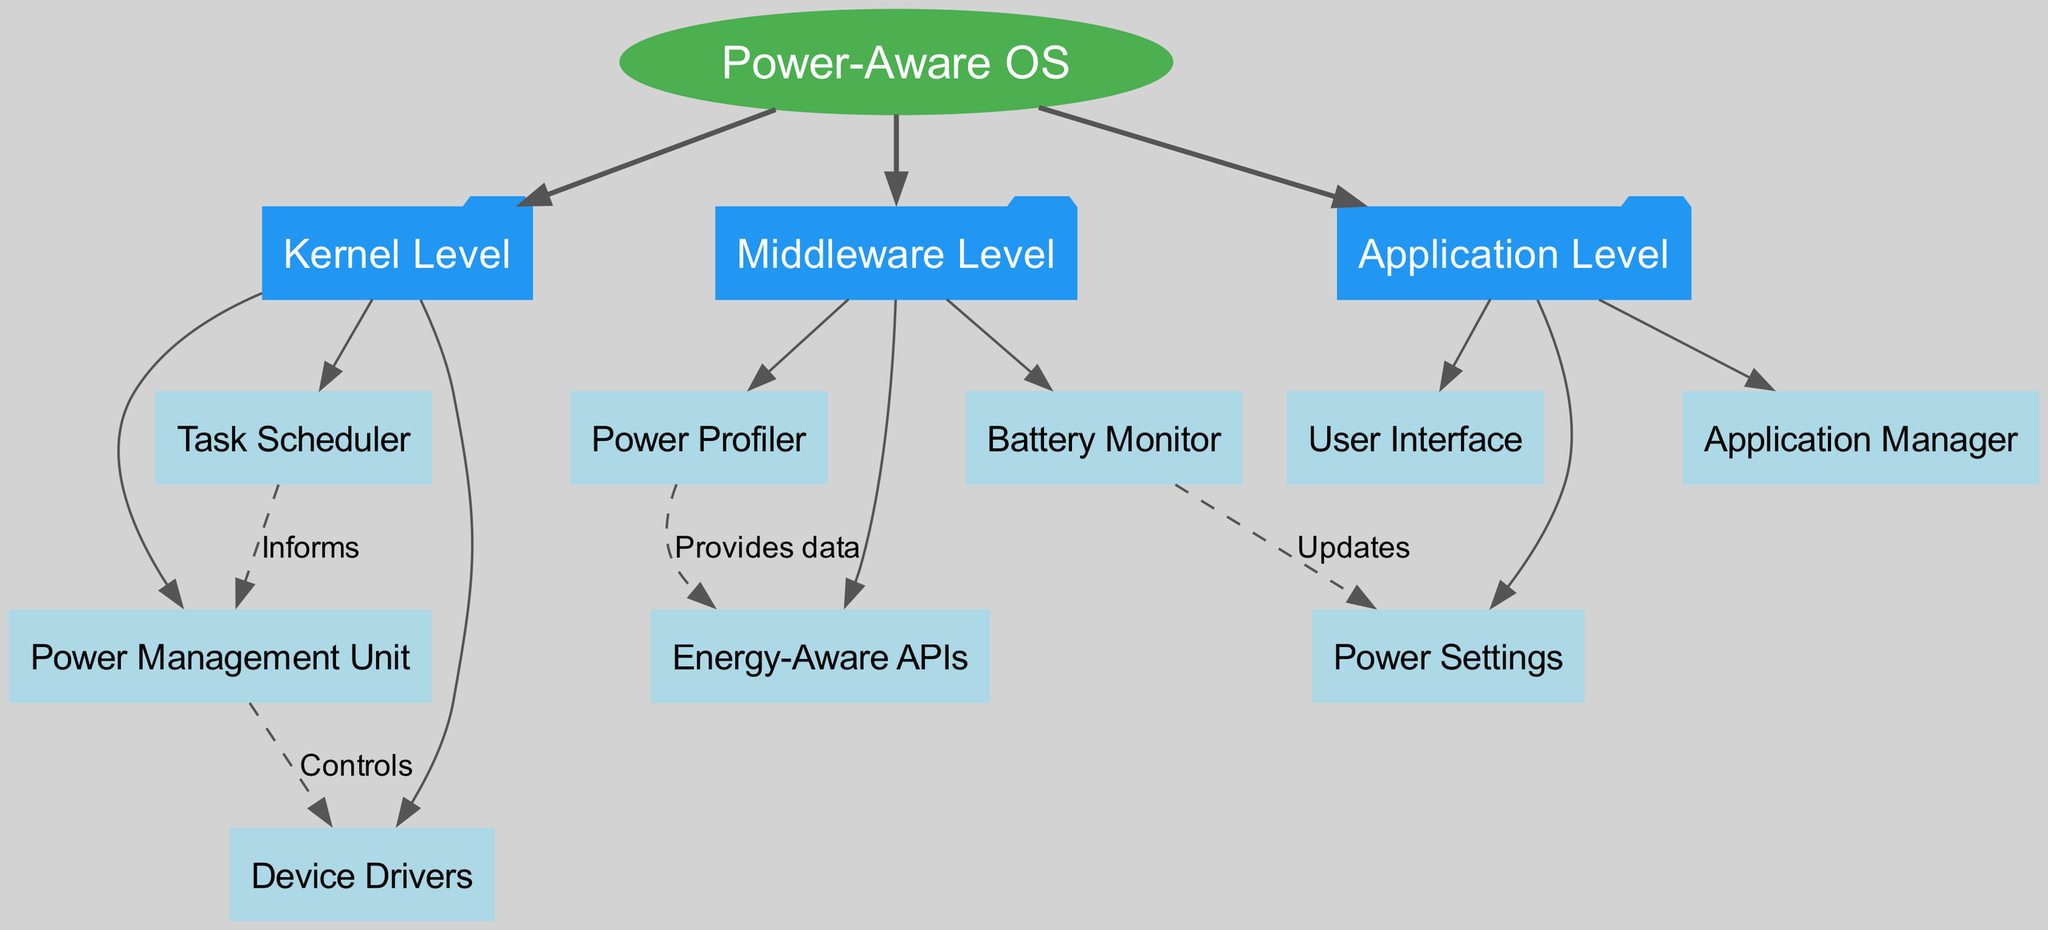What is the root node of the diagram? The root node is clearly labeled at the top of the hierarchy and represents the overarching concept of the diagram, which is "Power-Aware OS."
Answer: Power-Aware OS How many main branches are there in the diagram? The main branches are listed under the root node, and there are three specific branches identified: Kernel Level, Middleware Level, and Application Level.
Answer: 3 Which component controls the Device Drivers? By examining the connections illustrated in the diagram, it is evident that the "Power Management Unit" has a directional edge labeled "Controls" pointing to "Device Drivers."
Answer: Power Management Unit What does the Battery Monitor update? The connection labeled "Updates" in the diagram indicates that the "Battery Monitor" influences or modifies the "Power Settings."
Answer: Power Settings Which component informs the Power Management Unit? Reviewing the connections, we see that the "Task Scheduler" has the edge labeled "Informs" directed towards the "Power Management Unit," indicating this relationship.
Answer: Task Scheduler What relationship exists between Power Profiler and Energy-Aware APIs? The diagram shows an edge labeled "Provides data" from the "Power Profiler" to the "Energy-Aware APIs," which indicates the type of relationship.
Answer: Provides data How many children does the Middleware Level have? Under the Middleware Level branch, three specific children are listed: Power Profiler, Energy-Aware APIs, and Battery Monitor, counting them gives us the total.
Answer: 3 What is the visual representation type of the root node? The root node is characterized as an ellipse shape according to the graphical description given for the diagram.
Answer: Ellipse Which node is affected by the updates from the Battery Monitor? The connection indicated in the diagram shows that the "Battery Monitor" forwards updates to the "Power Settings." Hence, this is the affected node.
Answer: Power Settings 